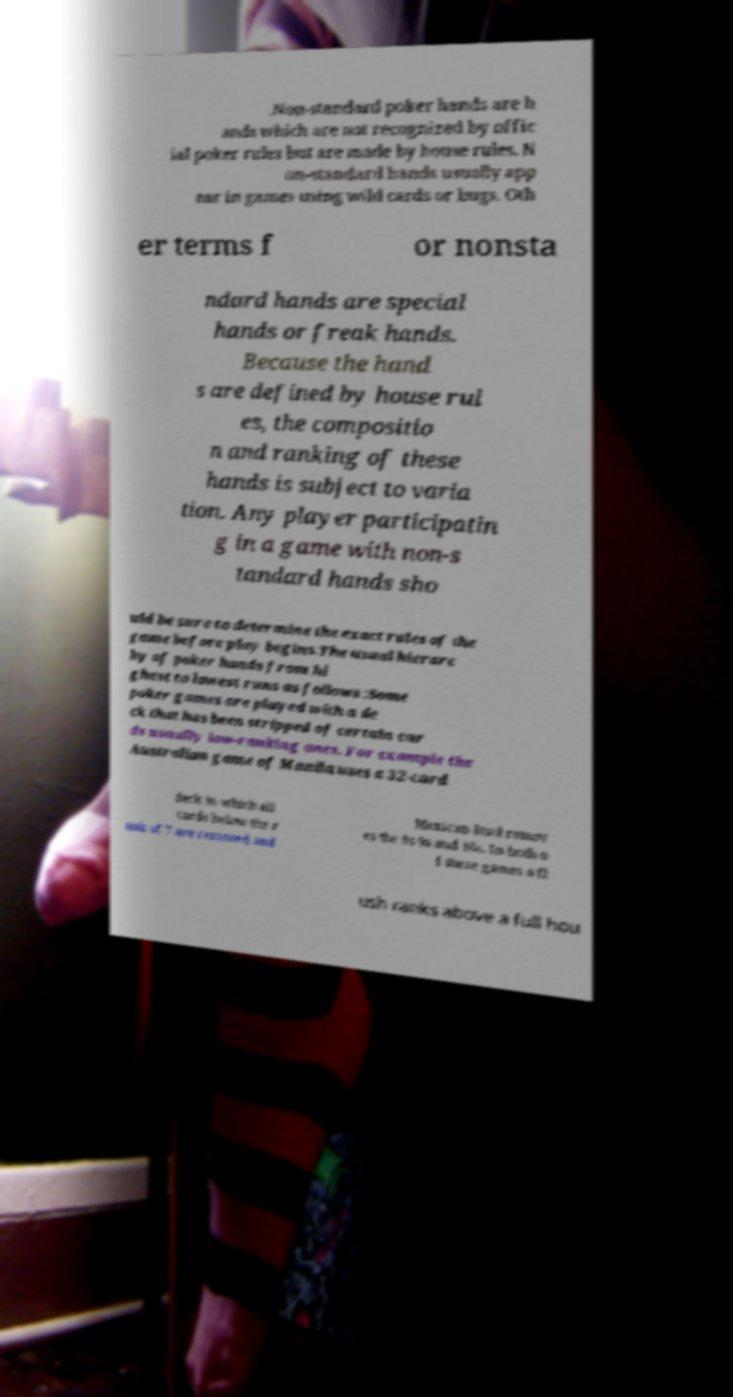Please identify and transcribe the text found in this image. .Non-standard poker hands are h ands which are not recognized by offic ial poker rules but are made by house rules. N on-standard hands usually app ear in games using wild cards or bugs. Oth er terms f or nonsta ndard hands are special hands or freak hands. Because the hand s are defined by house rul es, the compositio n and ranking of these hands is subject to varia tion. Any player participatin g in a game with non-s tandard hands sho uld be sure to determine the exact rules of the game before play begins.The usual hierarc hy of poker hands from hi ghest to lowest runs as follows :Some poker games are played with a de ck that has been stripped of certain car ds usually low-ranking ones. For example the Australian game of Manila uses a 32-card deck in which all cards below the r ank of 7 are removed and Mexican Stud remov es the 8s 9s and 10s. In both o f these games a fl ush ranks above a full hou 